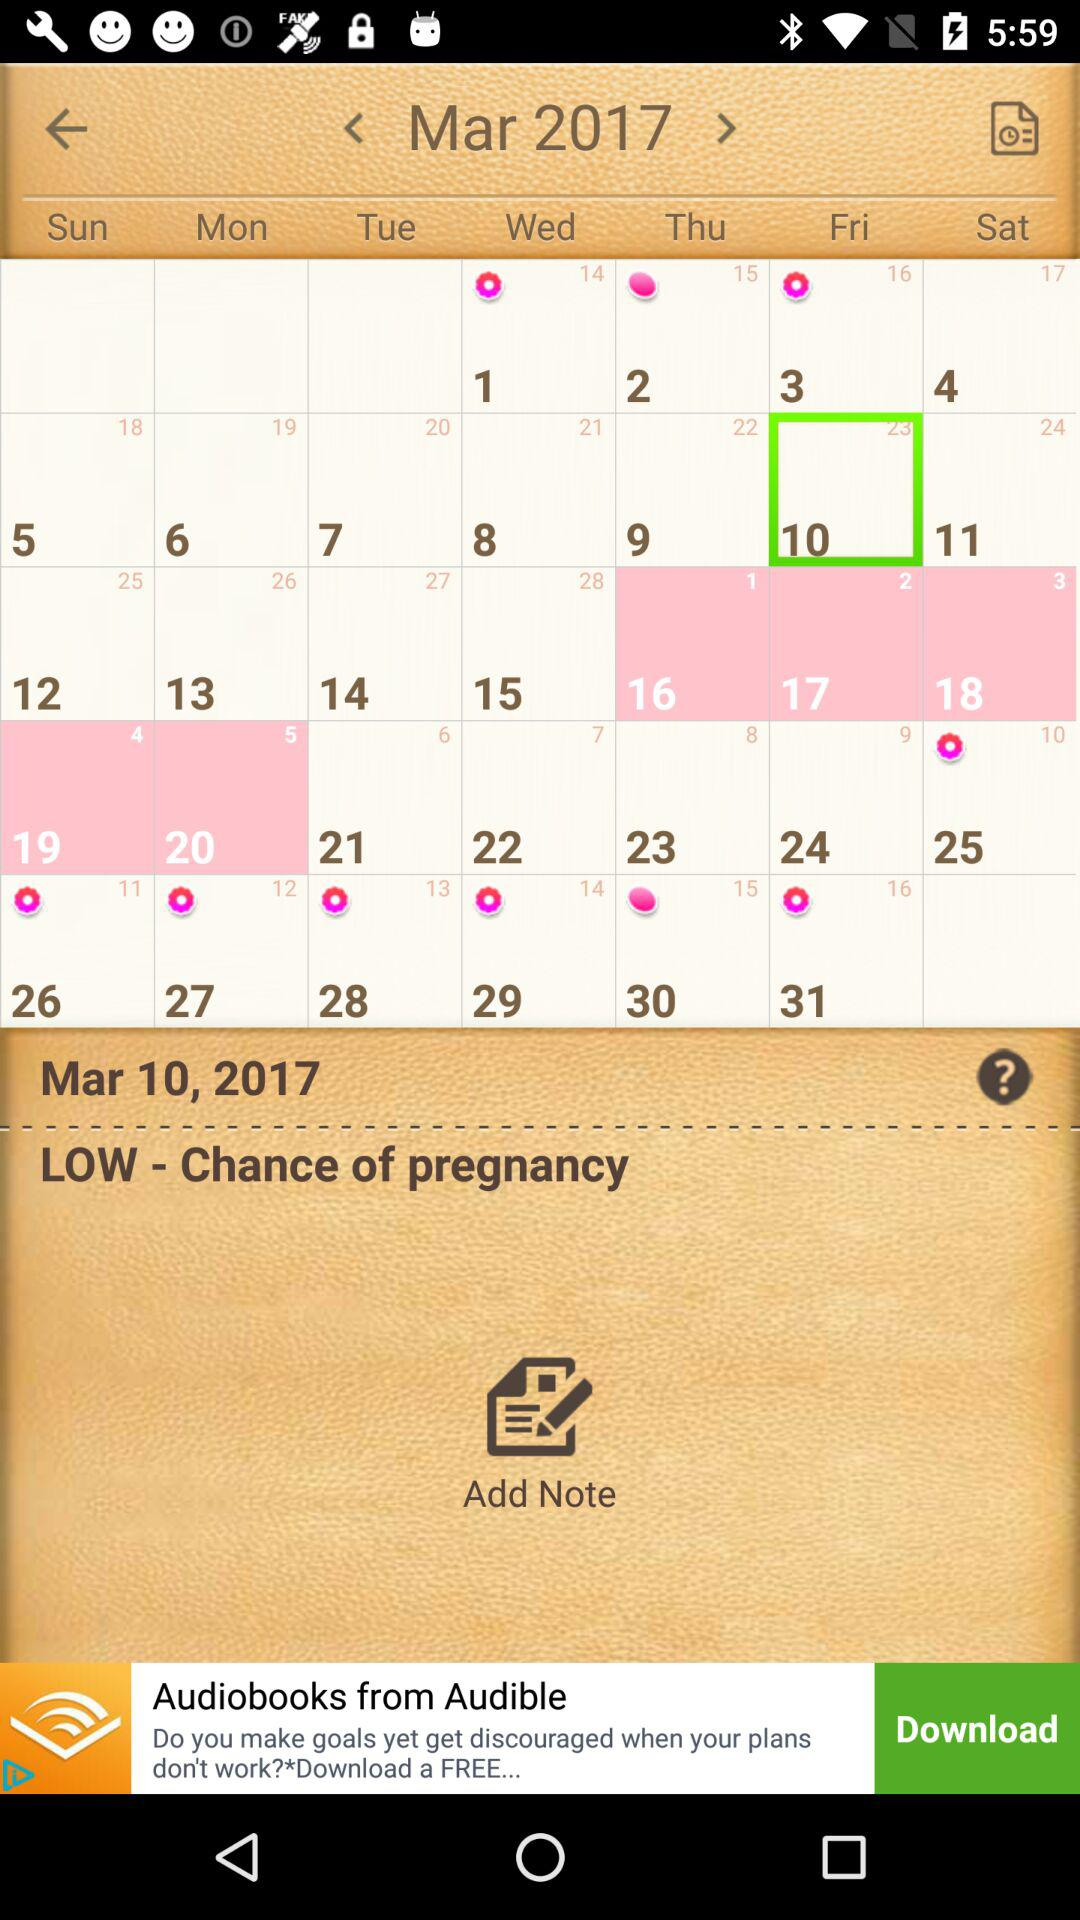What is the selected date? The selected date is March 10, 2017. 